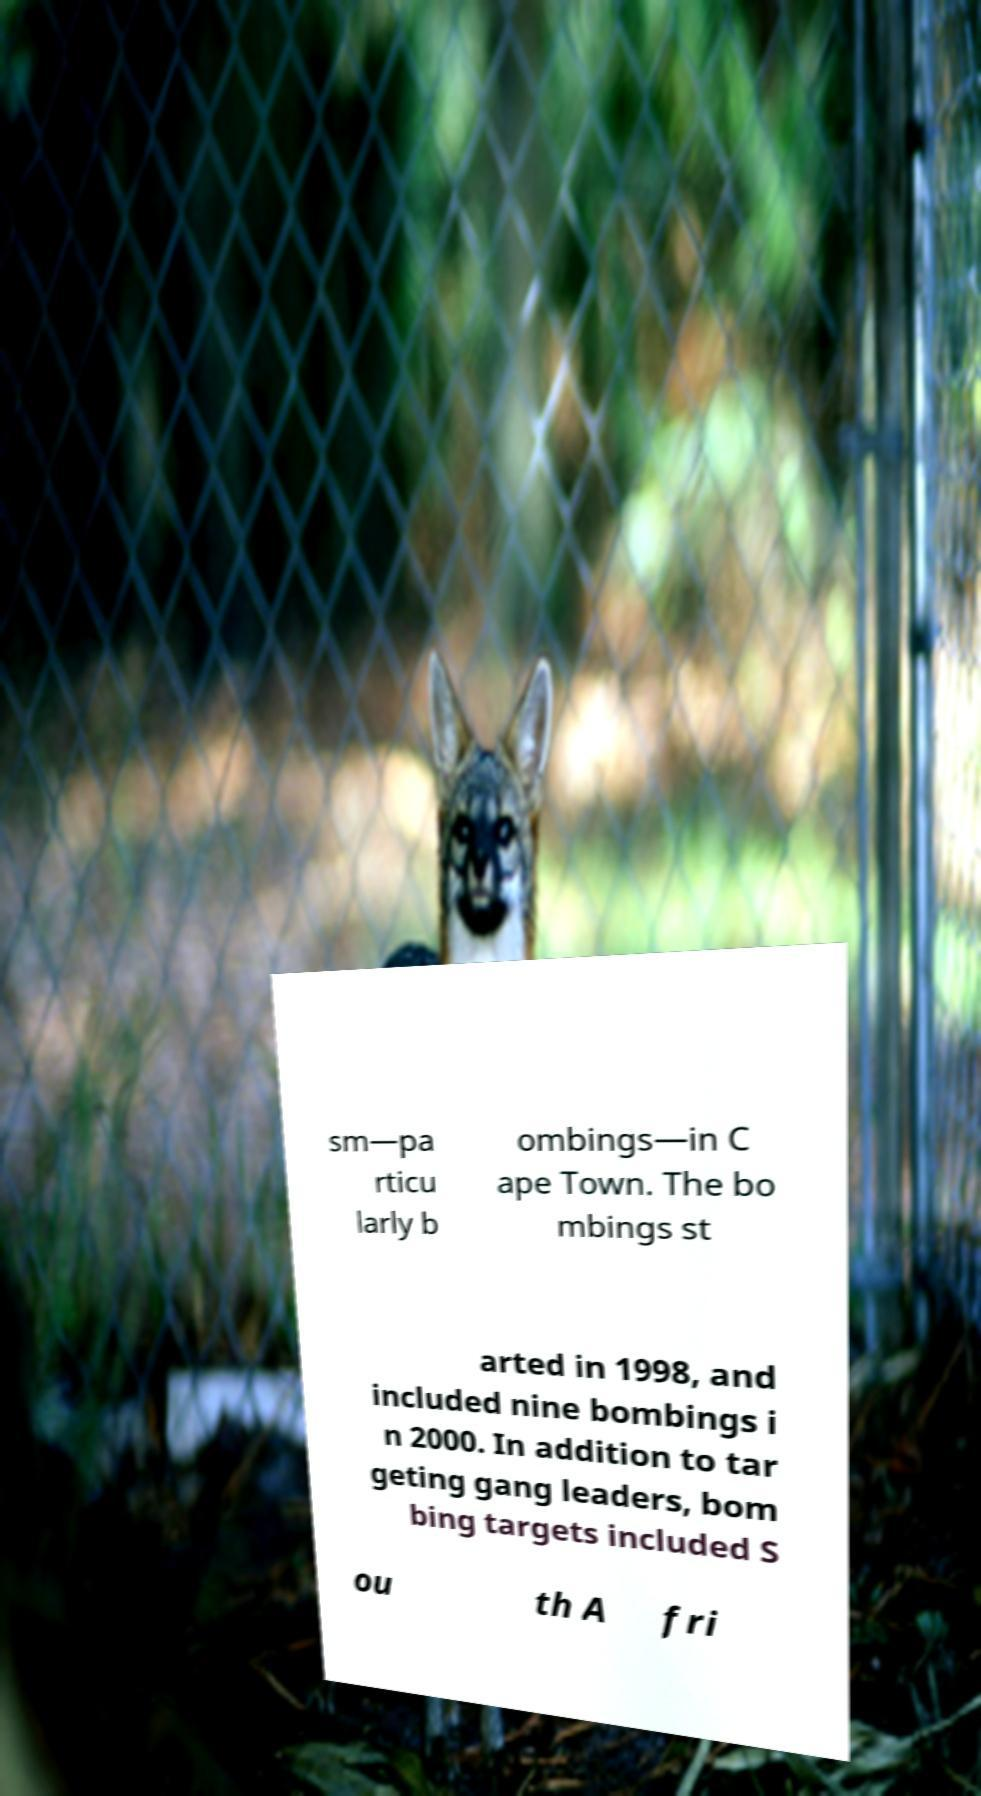What messages or text are displayed in this image? I need them in a readable, typed format. sm—pa rticu larly b ombings—in C ape Town. The bo mbings st arted in 1998, and included nine bombings i n 2000. In addition to tar geting gang leaders, bom bing targets included S ou th A fri 